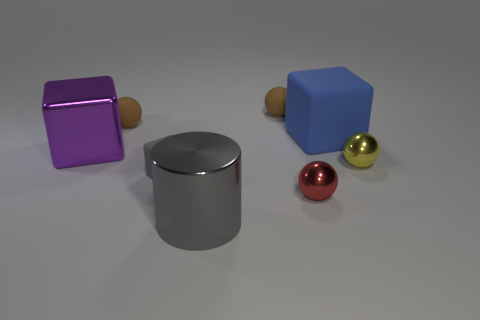How many other things are made of the same material as the gray cube?
Ensure brevity in your answer.  3. Is the shape of the purple metallic thing the same as the gray shiny object?
Offer a very short reply. No. How many cubes are the same size as the red metallic object?
Provide a short and direct response. 1. Are there fewer purple metallic objects that are in front of the gray rubber thing than big purple objects?
Offer a terse response. Yes. There is a cube that is right of the big metallic thing that is in front of the small yellow metallic sphere; what size is it?
Offer a very short reply. Large. What number of objects are either small red shiny objects or tiny matte spheres?
Ensure brevity in your answer.  3. Is there a tiny sphere of the same color as the large shiny cylinder?
Provide a short and direct response. No. Are there fewer big blue rubber objects than small brown matte cubes?
Offer a very short reply. No. What number of things are either yellow metal cylinders or rubber objects that are in front of the purple thing?
Your response must be concise. 1. Are there any cylinders that have the same material as the large purple object?
Your response must be concise. Yes. 